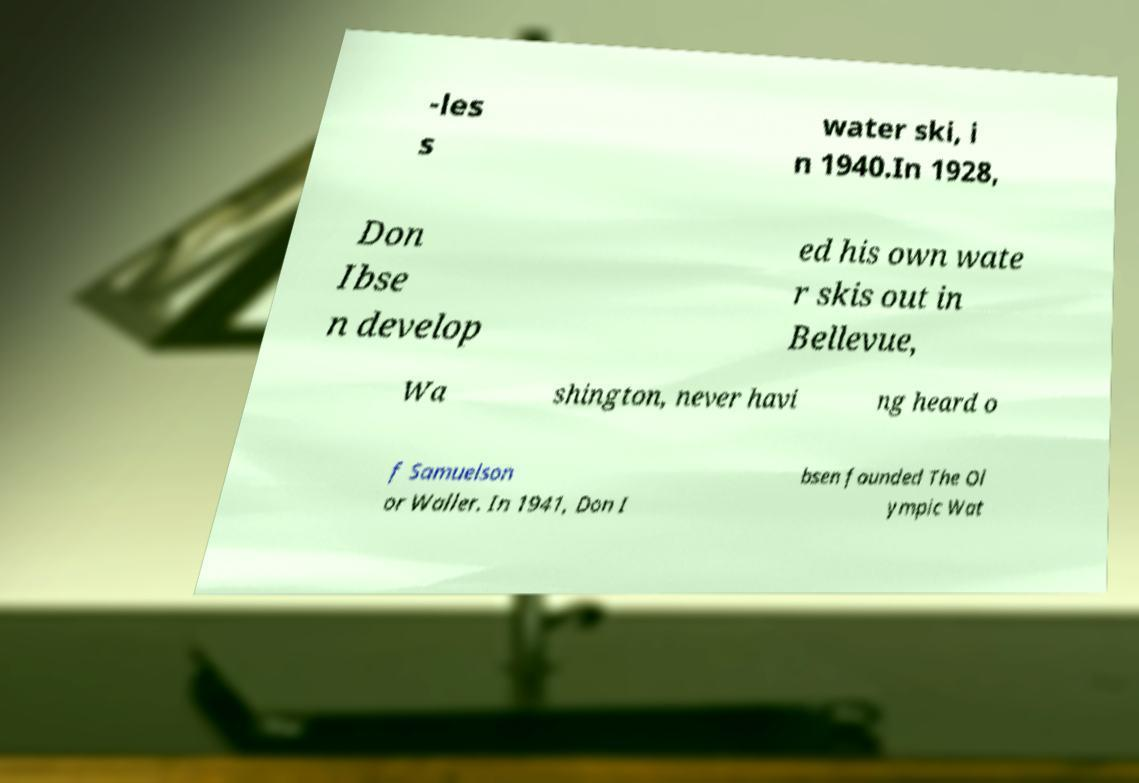For documentation purposes, I need the text within this image transcribed. Could you provide that? -les s water ski, i n 1940.In 1928, Don Ibse n develop ed his own wate r skis out in Bellevue, Wa shington, never havi ng heard o f Samuelson or Waller. In 1941, Don I bsen founded The Ol ympic Wat 